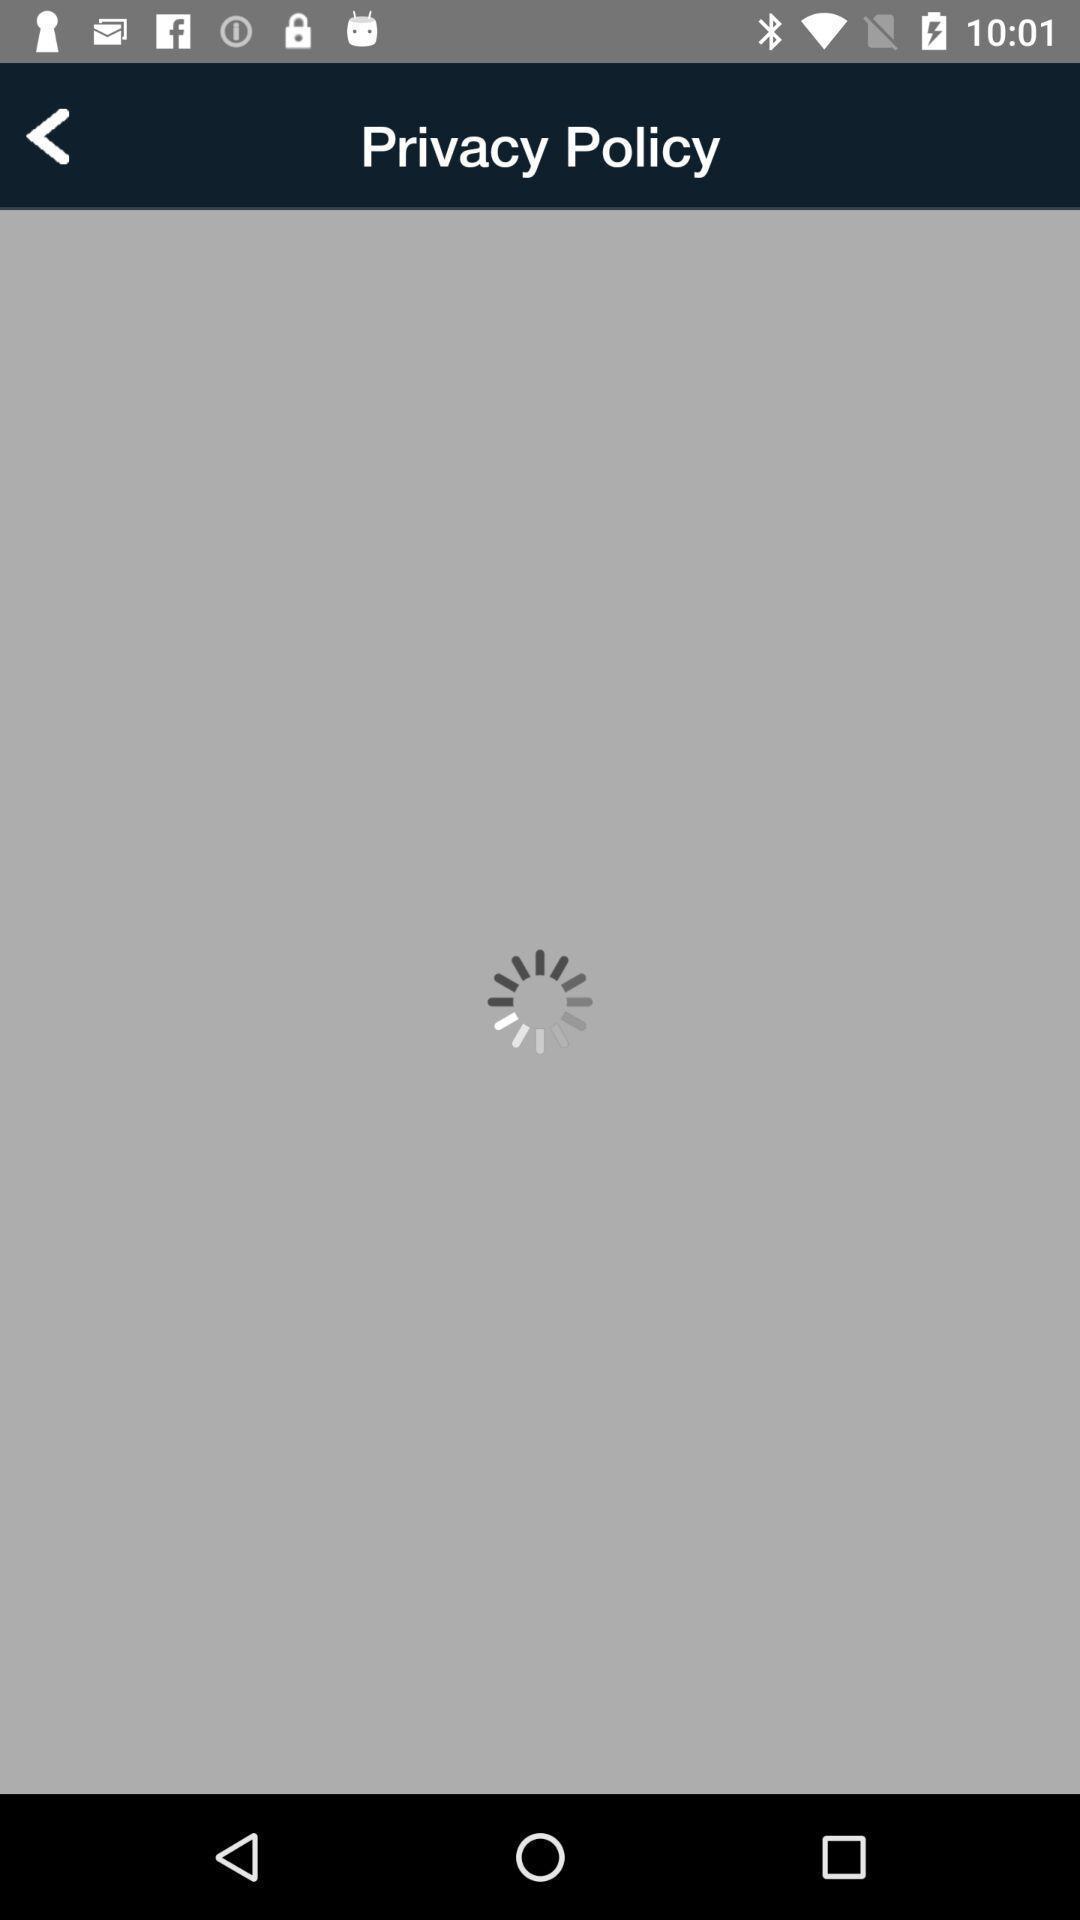Tell me what you see in this picture. Screen displaying loading page. 